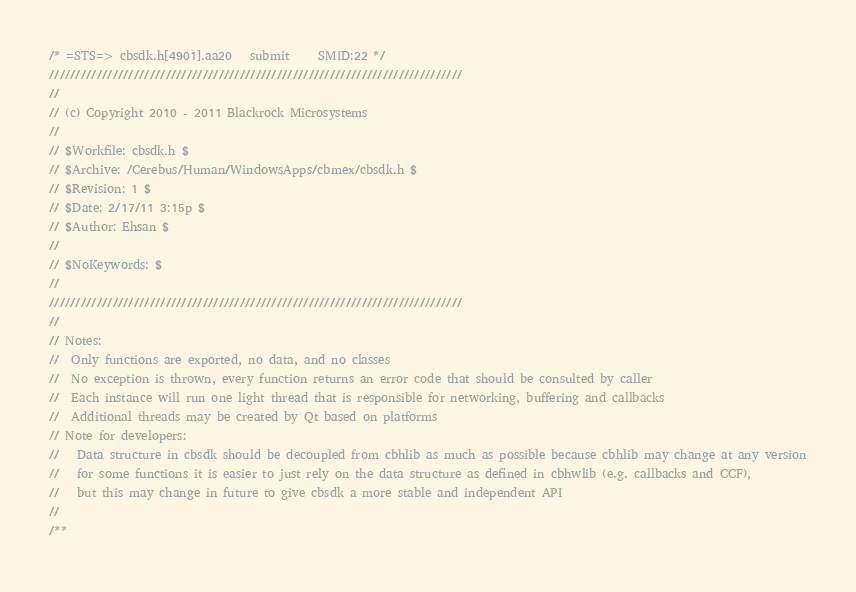<code> <loc_0><loc_0><loc_500><loc_500><_C_>/* =STS=> cbsdk.h[4901].aa20   submit     SMID:22 */
//////////////////////////////////////////////////////////////////////////////
//
// (c) Copyright 2010 - 2011 Blackrock Microsystems
//
// $Workfile: cbsdk.h $
// $Archive: /Cerebus/Human/WindowsApps/cbmex/cbsdk.h $
// $Revision: 1 $
// $Date: 2/17/11 3:15p $
// $Author: Ehsan $
//
// $NoKeywords: $
//
//////////////////////////////////////////////////////////////////////////////
//
// Notes:
//  Only functions are exported, no data, and no classes
//  No exception is thrown, every function returns an error code that should be consulted by caller
//  Each instance will run one light thread that is responsible for networking, buffering and callbacks
//  Additional threads may be created by Qt based on platforms
// Note for developers:
//   Data structure in cbsdk should be decoupled from cbhlib as much as possible because cbhlib may change at any version
//   for some functions it is easier to just rely on the data structure as defined in cbhwlib (e.g. callbacks and CCF),
//   but this may change in future to give cbsdk a more stable and independent API
//
/**</code> 